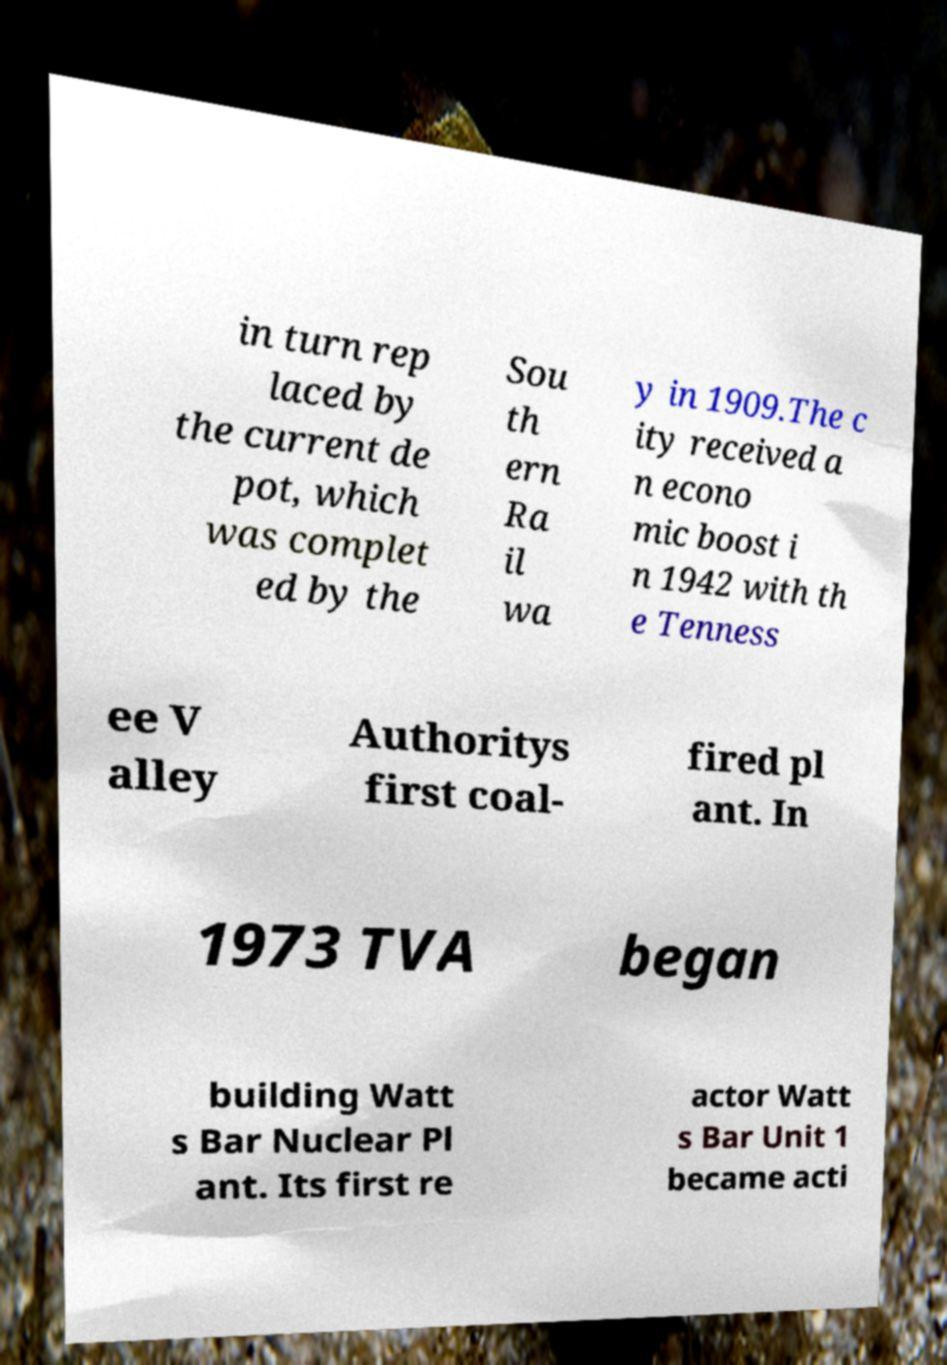For documentation purposes, I need the text within this image transcribed. Could you provide that? in turn rep laced by the current de pot, which was complet ed by the Sou th ern Ra il wa y in 1909.The c ity received a n econo mic boost i n 1942 with th e Tenness ee V alley Authoritys first coal- fired pl ant. In 1973 TVA began building Watt s Bar Nuclear Pl ant. Its first re actor Watt s Bar Unit 1 became acti 